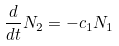<formula> <loc_0><loc_0><loc_500><loc_500>\frac { d } { d t } N _ { 2 } = - c _ { 1 } N _ { 1 }</formula> 